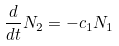<formula> <loc_0><loc_0><loc_500><loc_500>\frac { d } { d t } N _ { 2 } = - c _ { 1 } N _ { 1 }</formula> 